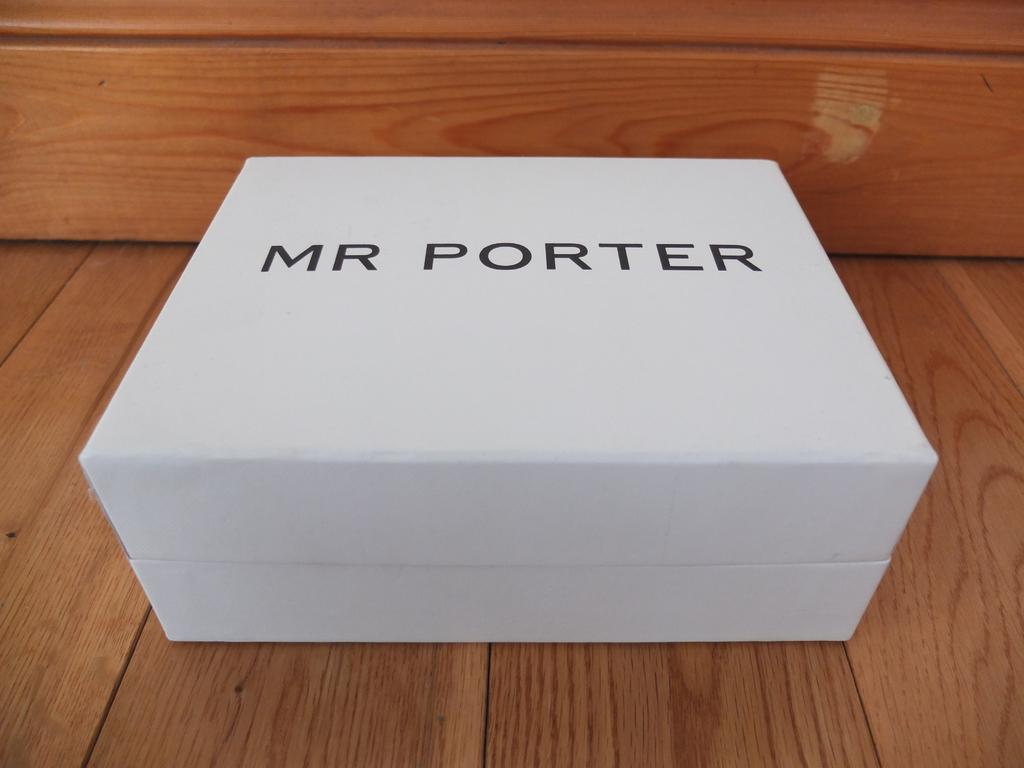Provide a one-sentence caption for the provided image. Large white box that says Mr Porter on the top. 